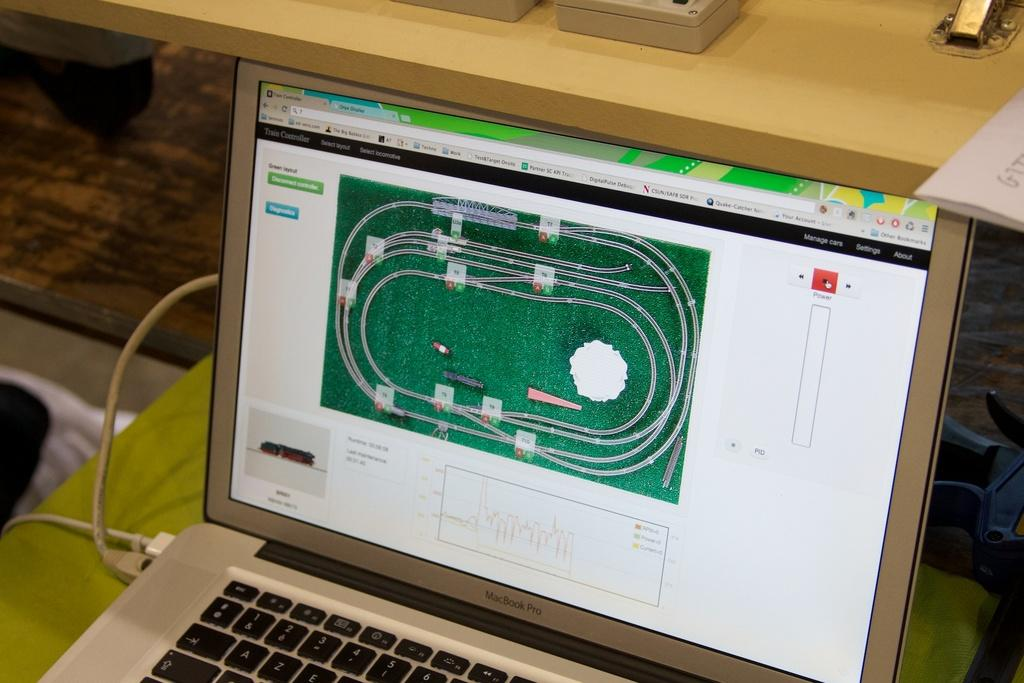<image>
Summarize the visual content of the image. A Macbook Pro laptap with an image of a miniature railroad. 